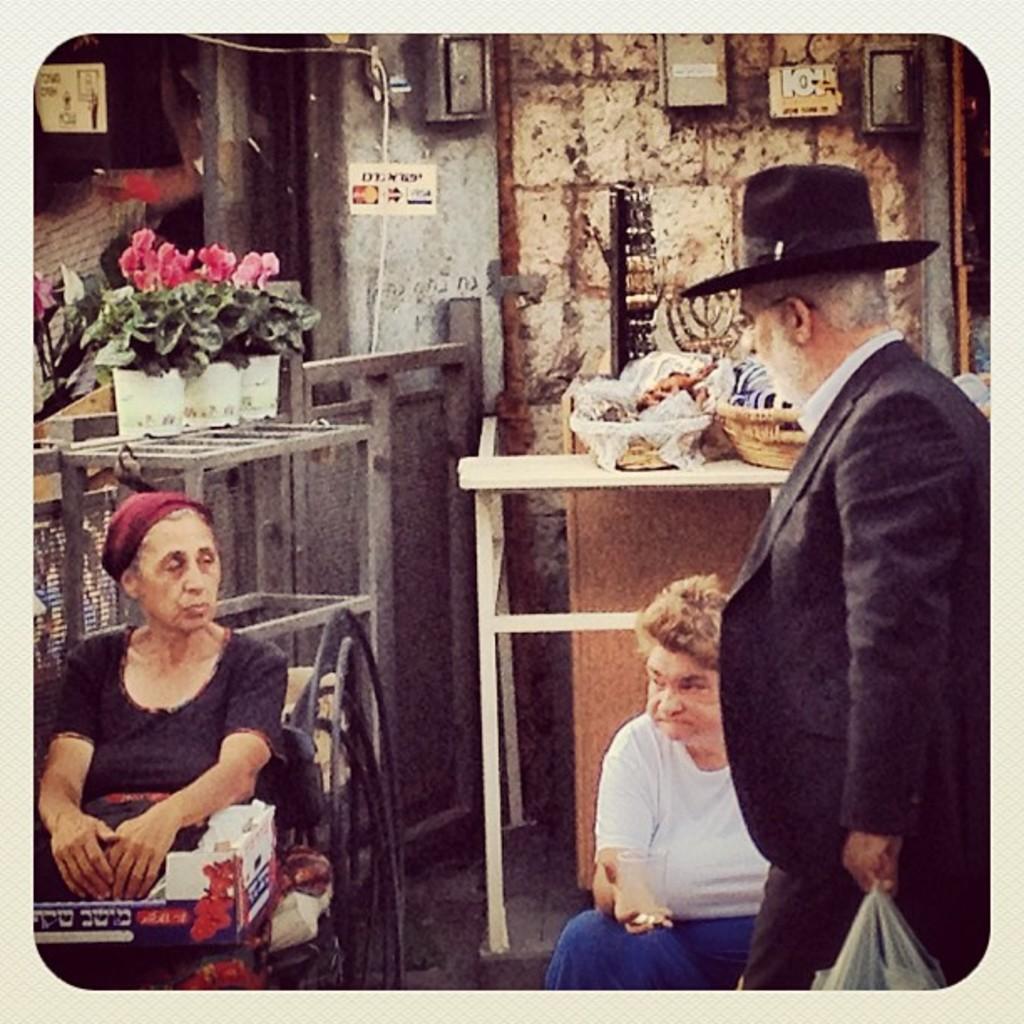In one or two sentences, can you explain what this image depicts? In this image I can see a woman wearing black dress is sitting, a person wearing white and blue dress is sitting and another person wearing black hat, black blazer and black pant is standing and holding a plastic bag in his hand. In the background I can see a table, few baskets on the table, few flower pots with plants and pink colored flowers in them, the wall and few boxes attached to the wall. 